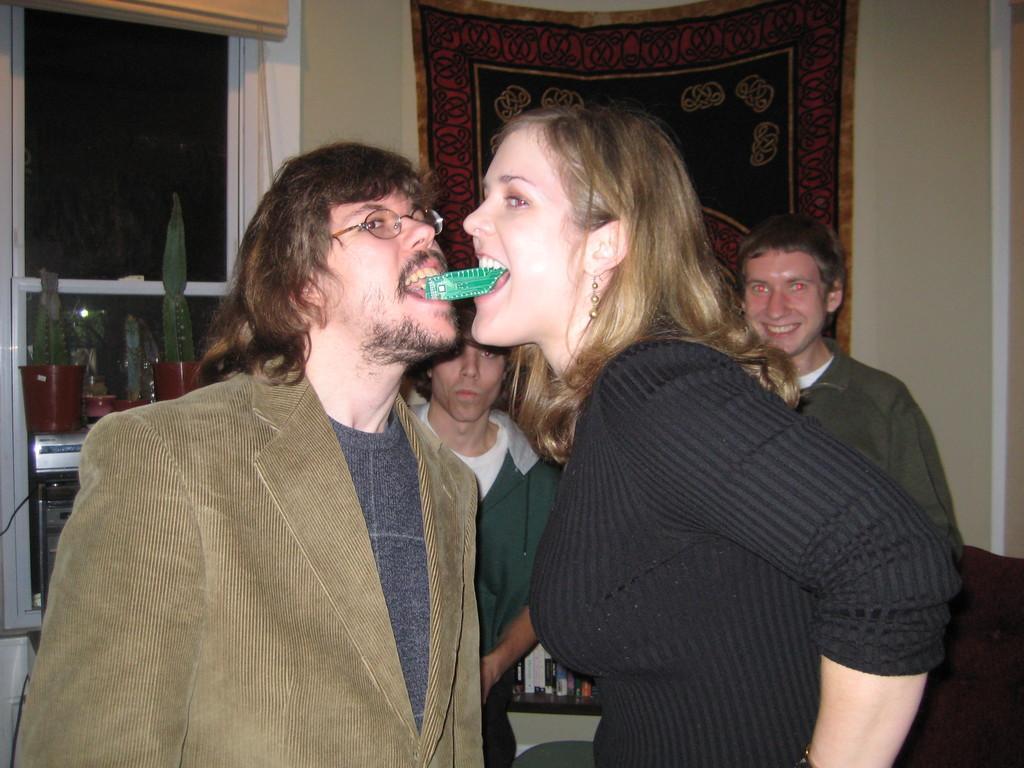In one or two sentences, can you explain what this image depicts? In this picture I can see two people holding green color object in their mouths. I can see a few people in the background. I can see glass window. 